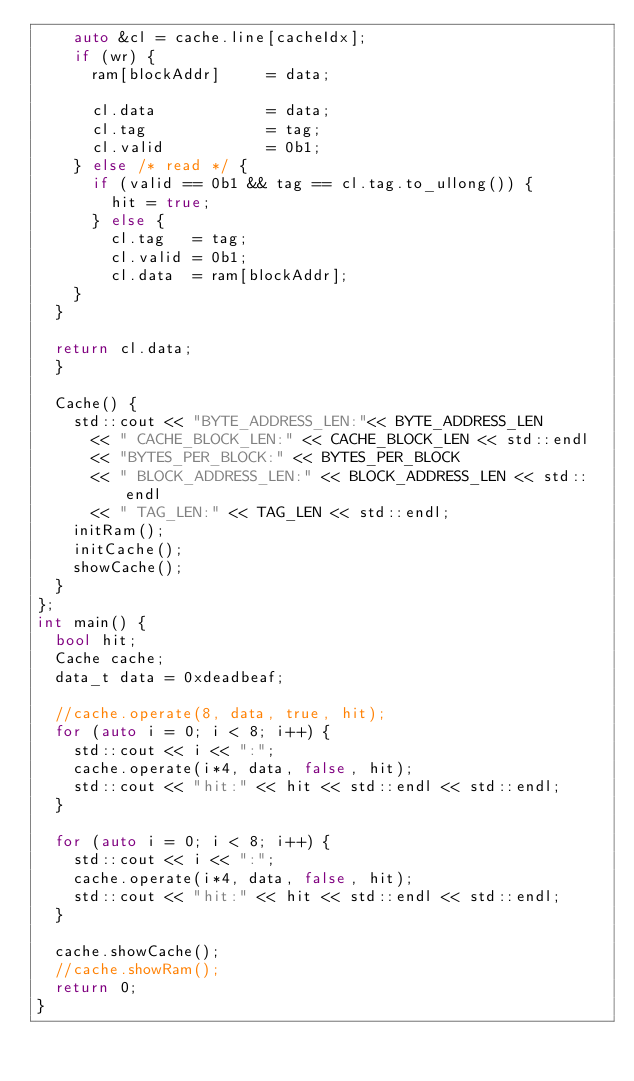<code> <loc_0><loc_0><loc_500><loc_500><_C++_>    auto &cl = cache.line[cacheIdx];
    if (wr) {
      ram[blockAddr]     = data;

      cl.data            = data;
      cl.tag             = tag;
      cl.valid           = 0b1;
    } else /* read */ {
      if (valid == 0b1 && tag == cl.tag.to_ullong()) {
        hit = true;
      } else {
        cl.tag   = tag;
        cl.valid = 0b1;
        cl.data  = ram[blockAddr];
    }
  }

  return cl.data;
  }

  Cache() {
    std::cout << "BYTE_ADDRESS_LEN:"<< BYTE_ADDRESS_LEN
      << " CACHE_BLOCK_LEN:" << CACHE_BLOCK_LEN << std::endl
      << "BYTES_PER_BLOCK:" << BYTES_PER_BLOCK
      << " BLOCK_ADDRESS_LEN:" << BLOCK_ADDRESS_LEN << std::endl
      << " TAG_LEN:" << TAG_LEN << std::endl;
    initRam();
    initCache();
    showCache();
  }
};
int main() {
  bool hit;
  Cache cache;
  data_t data = 0xdeadbeaf;

  //cache.operate(8, data, true, hit);
  for (auto i = 0; i < 8; i++) {
    std::cout << i << ":";
    cache.operate(i*4, data, false, hit);
    std::cout << "hit:" << hit << std::endl << std::endl;
  }

  for (auto i = 0; i < 8; i++) {
    std::cout << i << ":";
    cache.operate(i*4, data, false, hit);
    std::cout << "hit:" << hit << std::endl << std::endl;
  }

  cache.showCache();
  //cache.showRam();
  return 0;
}
</code> 